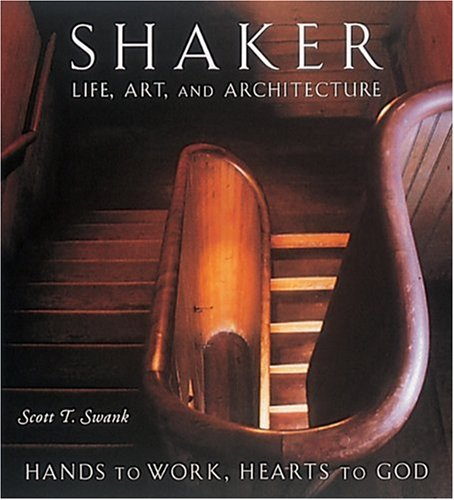What is the title of this book? The title of this book is 'Shaker Life, Art, and Architecture: Hands to Work, Hearts to God,' which explores the ascetic life, artistic contributions, and unique architectural designs of the Shaker community. 